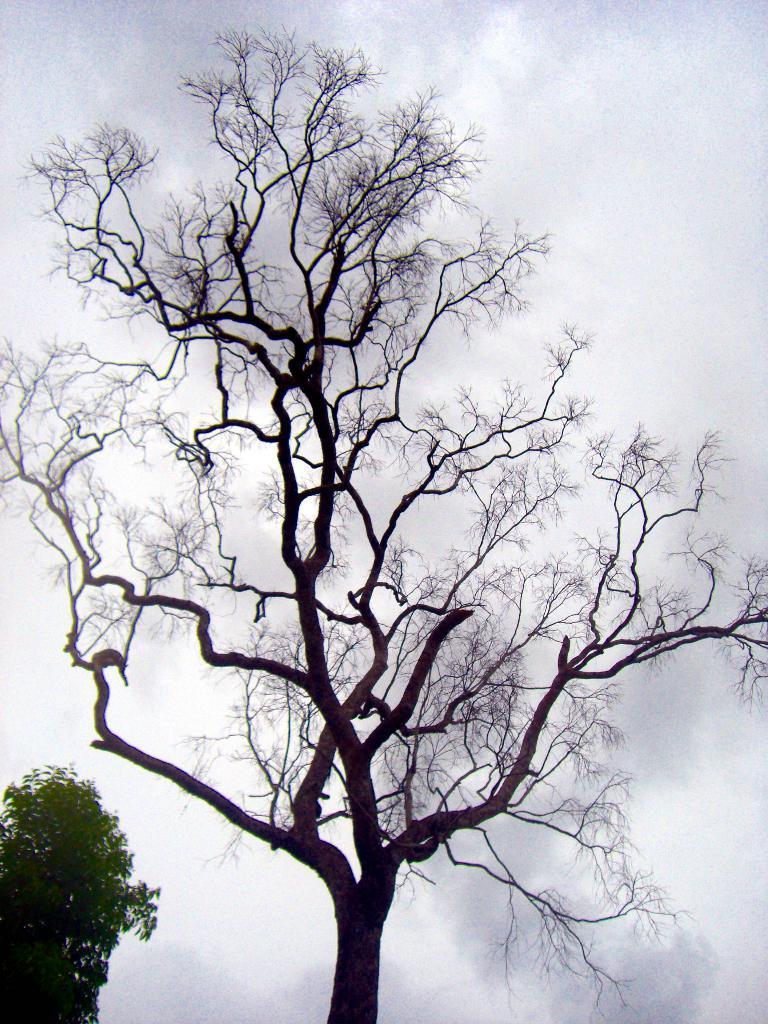Describe this image in one or two sentences. In this image we can see one big bare tree, left side of the image one green tree and there is the cloudy sky in the background. 